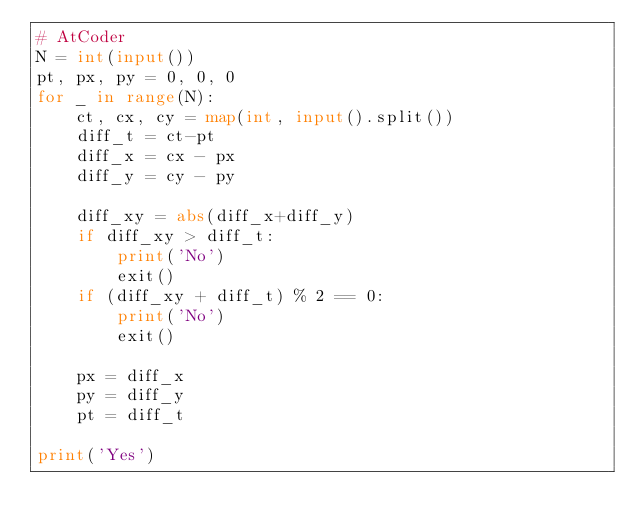Convert code to text. <code><loc_0><loc_0><loc_500><loc_500><_Python_># AtCoder
N = int(input())
pt, px, py = 0, 0, 0
for _ in range(N):
    ct, cx, cy = map(int, input().split())
    diff_t = ct-pt
    diff_x = cx - px
    diff_y = cy - py

    diff_xy = abs(diff_x+diff_y)
    if diff_xy > diff_t:
        print('No')
        exit()
    if (diff_xy + diff_t) % 2 == 0:
        print('No')
        exit()

    px = diff_x
    py = diff_y
    pt = diff_t

print('Yes')
</code> 